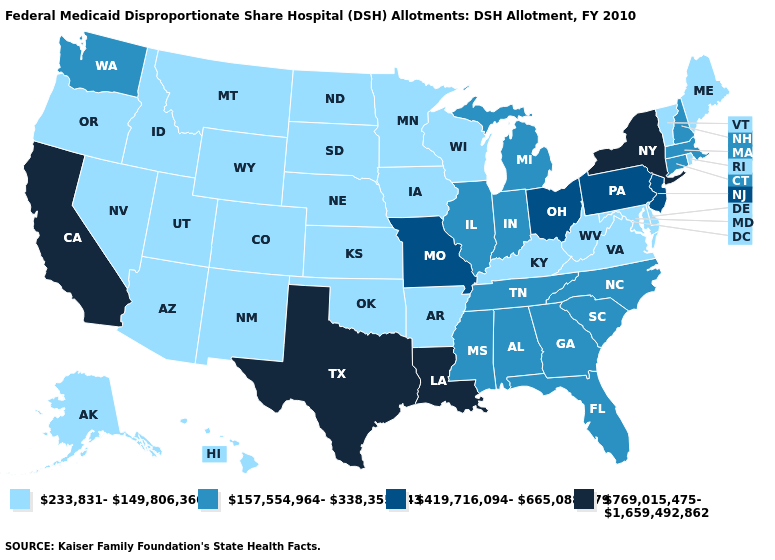What is the value of Pennsylvania?
Write a very short answer. 419,716,094-665,088,579. How many symbols are there in the legend?
Concise answer only. 4. What is the value of West Virginia?
Be succinct. 233,831-149,806,360. What is the value of Mississippi?
Concise answer only. 157,554,964-338,355,743. Which states have the lowest value in the USA?
Be succinct. Alaska, Arizona, Arkansas, Colorado, Delaware, Hawaii, Idaho, Iowa, Kansas, Kentucky, Maine, Maryland, Minnesota, Montana, Nebraska, Nevada, New Mexico, North Dakota, Oklahoma, Oregon, Rhode Island, South Dakota, Utah, Vermont, Virginia, West Virginia, Wisconsin, Wyoming. Name the states that have a value in the range 769,015,475-1,659,492,862?
Answer briefly. California, Louisiana, New York, Texas. What is the highest value in states that border Mississippi?
Be succinct. 769,015,475-1,659,492,862. Among the states that border Tennessee , which have the highest value?
Write a very short answer. Missouri. Which states have the lowest value in the MidWest?
Give a very brief answer. Iowa, Kansas, Minnesota, Nebraska, North Dakota, South Dakota, Wisconsin. Does Tennessee have the highest value in the South?
Answer briefly. No. Which states have the highest value in the USA?
Write a very short answer. California, Louisiana, New York, Texas. What is the highest value in the South ?
Answer briefly. 769,015,475-1,659,492,862. Does the first symbol in the legend represent the smallest category?
Short answer required. Yes. What is the value of Wyoming?
Short answer required. 233,831-149,806,360. Name the states that have a value in the range 419,716,094-665,088,579?
Answer briefly. Missouri, New Jersey, Ohio, Pennsylvania. 